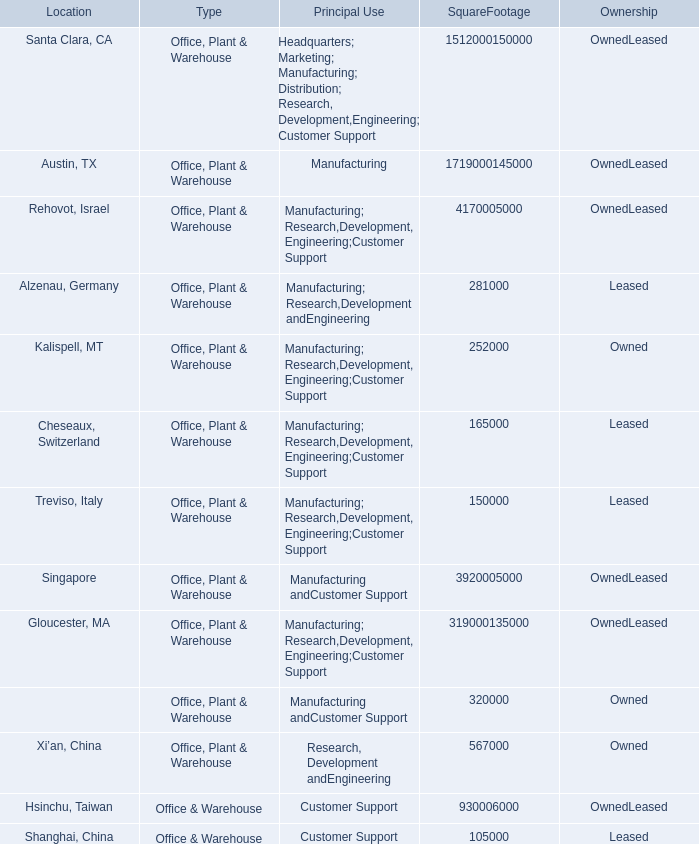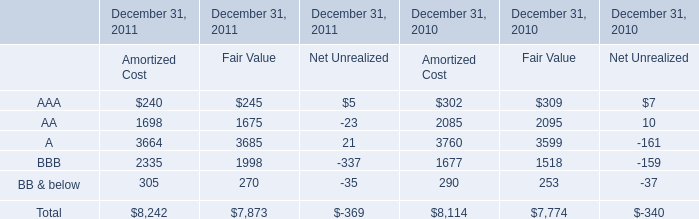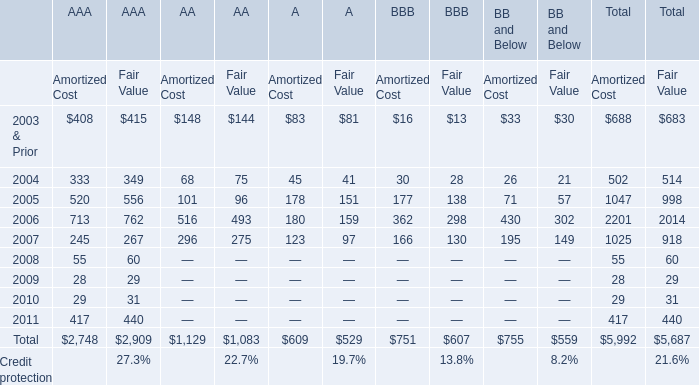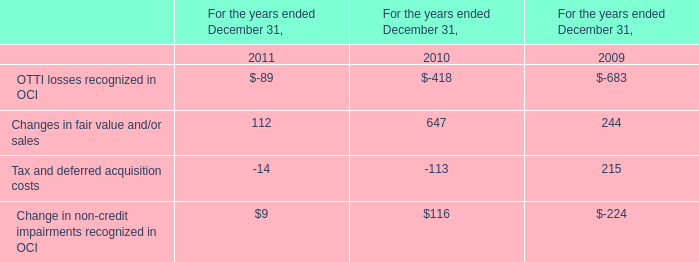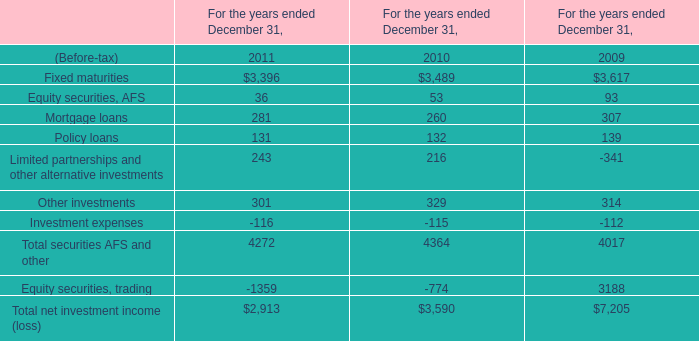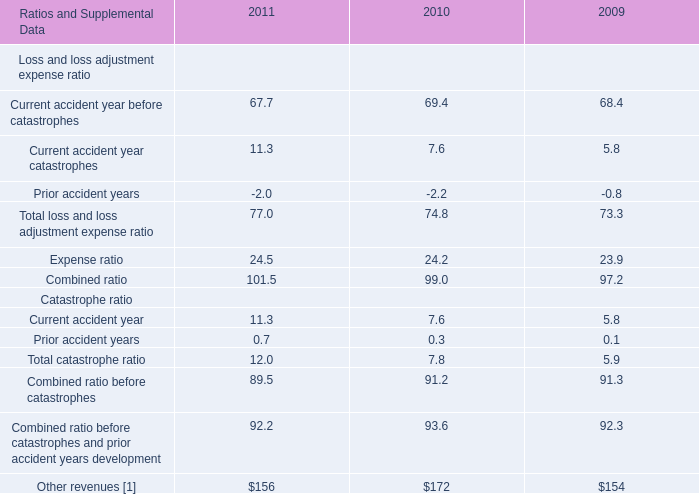What is the average amount of Rehovot, Israel of SquareFootage 1,512,000150,000, and AA of December 31, 2010 Amortized Cost ? 
Computations: ((4170005000.0 + 2085.0) / 2)
Answer: 2085003542.5. 